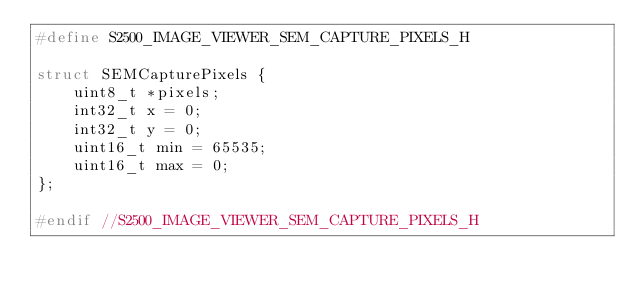<code> <loc_0><loc_0><loc_500><loc_500><_C_>#define S2500_IMAGE_VIEWER_SEM_CAPTURE_PIXELS_H

struct SEMCapturePixels {
    uint8_t *pixels;
    int32_t x = 0;
    int32_t y = 0;
    uint16_t min = 65535;
    uint16_t max = 0;
};

#endif //S2500_IMAGE_VIEWER_SEM_CAPTURE_PIXELS_H
</code> 